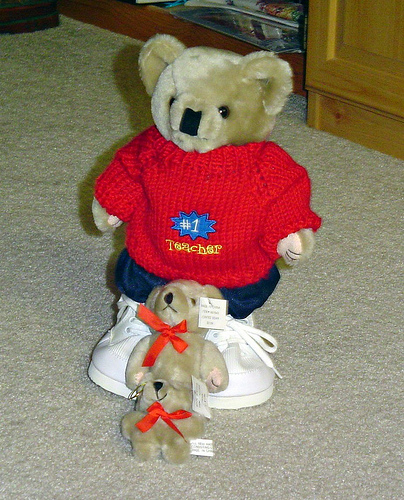<image>
Is the cabinet behind the bear? Yes. From this viewpoint, the cabinet is positioned behind the bear, with the bear partially or fully occluding the cabinet. Is the big bear above the medium bear? No. The big bear is not positioned above the medium bear. The vertical arrangement shows a different relationship. 